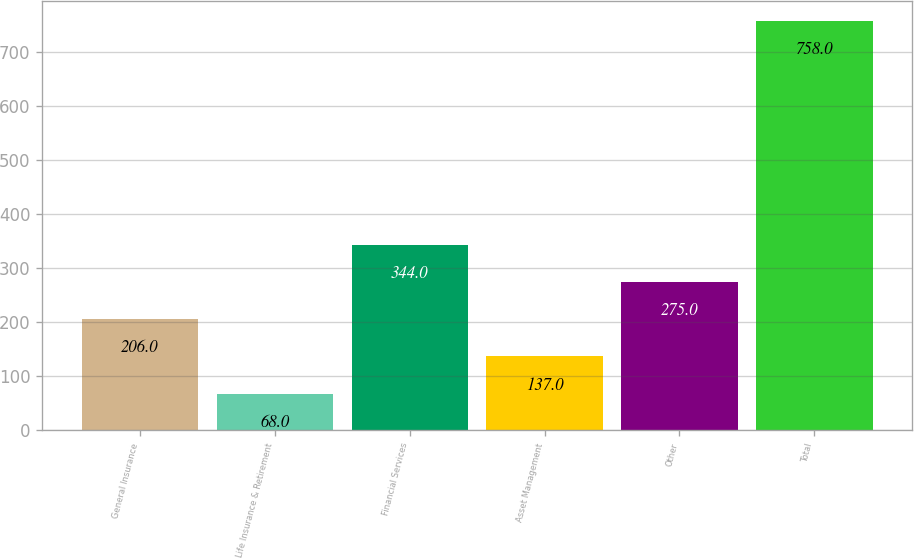Convert chart to OTSL. <chart><loc_0><loc_0><loc_500><loc_500><bar_chart><fcel>General Insurance<fcel>Life Insurance & Retirement<fcel>Financial Services<fcel>Asset Management<fcel>Other<fcel>Total<nl><fcel>206<fcel>68<fcel>344<fcel>137<fcel>275<fcel>758<nl></chart> 